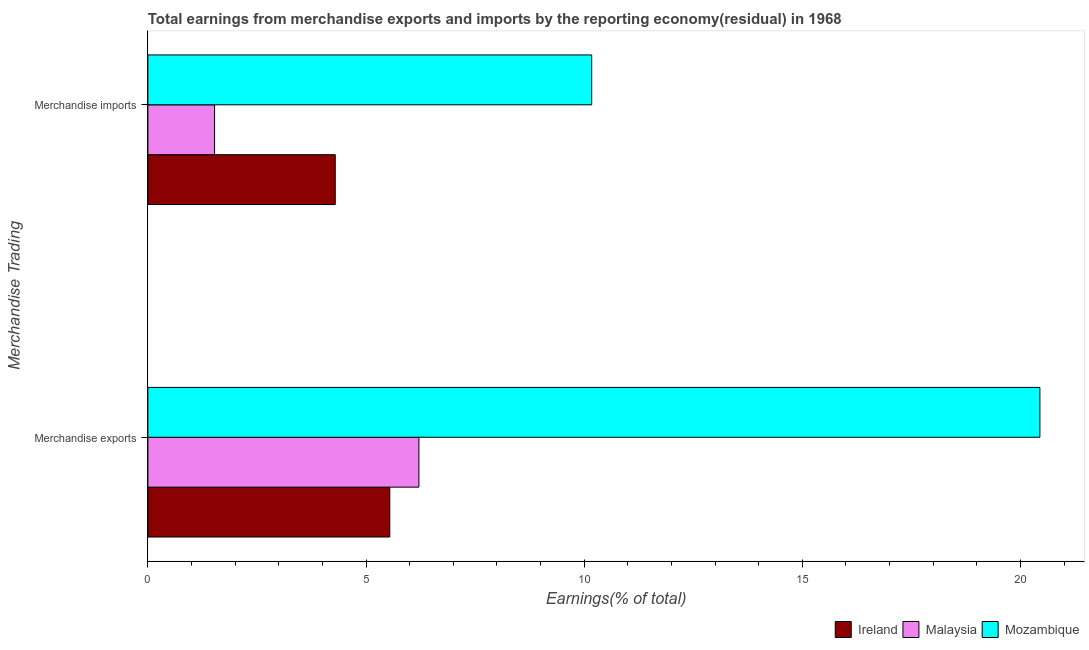Are the number of bars per tick equal to the number of legend labels?
Your answer should be compact. Yes. How many bars are there on the 2nd tick from the top?
Make the answer very short. 3. What is the earnings from merchandise exports in Malaysia?
Your answer should be very brief. 6.21. Across all countries, what is the maximum earnings from merchandise exports?
Your answer should be compact. 20.44. Across all countries, what is the minimum earnings from merchandise exports?
Your response must be concise. 5.54. In which country was the earnings from merchandise exports maximum?
Offer a terse response. Mozambique. In which country was the earnings from merchandise imports minimum?
Your answer should be compact. Malaysia. What is the total earnings from merchandise exports in the graph?
Your response must be concise. 32.2. What is the difference between the earnings from merchandise exports in Mozambique and that in Ireland?
Your answer should be compact. 14.9. What is the difference between the earnings from merchandise exports in Malaysia and the earnings from merchandise imports in Ireland?
Keep it short and to the point. 1.92. What is the average earnings from merchandise exports per country?
Make the answer very short. 10.73. What is the difference between the earnings from merchandise imports and earnings from merchandise exports in Ireland?
Your answer should be very brief. -1.25. In how many countries, is the earnings from merchandise imports greater than 16 %?
Offer a terse response. 0. What is the ratio of the earnings from merchandise exports in Mozambique to that in Ireland?
Offer a very short reply. 3.69. Is the earnings from merchandise imports in Ireland less than that in Malaysia?
Your answer should be compact. No. What does the 1st bar from the top in Merchandise exports represents?
Ensure brevity in your answer.  Mozambique. What does the 3rd bar from the bottom in Merchandise exports represents?
Your response must be concise. Mozambique. Are all the bars in the graph horizontal?
Provide a short and direct response. Yes. What is the difference between two consecutive major ticks on the X-axis?
Keep it short and to the point. 5. Does the graph contain grids?
Your response must be concise. No. Where does the legend appear in the graph?
Offer a very short reply. Bottom right. How many legend labels are there?
Your response must be concise. 3. How are the legend labels stacked?
Provide a short and direct response. Horizontal. What is the title of the graph?
Ensure brevity in your answer.  Total earnings from merchandise exports and imports by the reporting economy(residual) in 1968. What is the label or title of the X-axis?
Offer a very short reply. Earnings(% of total). What is the label or title of the Y-axis?
Your answer should be compact. Merchandise Trading. What is the Earnings(% of total) of Ireland in Merchandise exports?
Offer a very short reply. 5.54. What is the Earnings(% of total) in Malaysia in Merchandise exports?
Keep it short and to the point. 6.21. What is the Earnings(% of total) in Mozambique in Merchandise exports?
Make the answer very short. 20.44. What is the Earnings(% of total) of Ireland in Merchandise imports?
Offer a very short reply. 4.29. What is the Earnings(% of total) of Malaysia in Merchandise imports?
Offer a terse response. 1.53. What is the Earnings(% of total) of Mozambique in Merchandise imports?
Your response must be concise. 10.17. Across all Merchandise Trading, what is the maximum Earnings(% of total) of Ireland?
Ensure brevity in your answer.  5.54. Across all Merchandise Trading, what is the maximum Earnings(% of total) in Malaysia?
Offer a very short reply. 6.21. Across all Merchandise Trading, what is the maximum Earnings(% of total) of Mozambique?
Give a very brief answer. 20.44. Across all Merchandise Trading, what is the minimum Earnings(% of total) of Ireland?
Keep it short and to the point. 4.29. Across all Merchandise Trading, what is the minimum Earnings(% of total) in Malaysia?
Keep it short and to the point. 1.53. Across all Merchandise Trading, what is the minimum Earnings(% of total) in Mozambique?
Provide a succinct answer. 10.17. What is the total Earnings(% of total) in Ireland in the graph?
Your answer should be very brief. 9.84. What is the total Earnings(% of total) in Malaysia in the graph?
Your answer should be very brief. 7.74. What is the total Earnings(% of total) in Mozambique in the graph?
Keep it short and to the point. 30.62. What is the difference between the Earnings(% of total) in Ireland in Merchandise exports and that in Merchandise imports?
Give a very brief answer. 1.25. What is the difference between the Earnings(% of total) in Malaysia in Merchandise exports and that in Merchandise imports?
Provide a short and direct response. 4.68. What is the difference between the Earnings(% of total) in Mozambique in Merchandise exports and that in Merchandise imports?
Provide a short and direct response. 10.27. What is the difference between the Earnings(% of total) of Ireland in Merchandise exports and the Earnings(% of total) of Malaysia in Merchandise imports?
Offer a very short reply. 4.02. What is the difference between the Earnings(% of total) in Ireland in Merchandise exports and the Earnings(% of total) in Mozambique in Merchandise imports?
Your answer should be compact. -4.63. What is the difference between the Earnings(% of total) of Malaysia in Merchandise exports and the Earnings(% of total) of Mozambique in Merchandise imports?
Offer a very short reply. -3.96. What is the average Earnings(% of total) in Ireland per Merchandise Trading?
Give a very brief answer. 4.92. What is the average Earnings(% of total) of Malaysia per Merchandise Trading?
Offer a very short reply. 3.87. What is the average Earnings(% of total) of Mozambique per Merchandise Trading?
Give a very brief answer. 15.31. What is the difference between the Earnings(% of total) of Ireland and Earnings(% of total) of Malaysia in Merchandise exports?
Offer a very short reply. -0.67. What is the difference between the Earnings(% of total) of Ireland and Earnings(% of total) of Mozambique in Merchandise exports?
Offer a terse response. -14.9. What is the difference between the Earnings(% of total) of Malaysia and Earnings(% of total) of Mozambique in Merchandise exports?
Keep it short and to the point. -14.23. What is the difference between the Earnings(% of total) of Ireland and Earnings(% of total) of Malaysia in Merchandise imports?
Your answer should be compact. 2.77. What is the difference between the Earnings(% of total) in Ireland and Earnings(% of total) in Mozambique in Merchandise imports?
Keep it short and to the point. -5.88. What is the difference between the Earnings(% of total) in Malaysia and Earnings(% of total) in Mozambique in Merchandise imports?
Your response must be concise. -8.64. What is the ratio of the Earnings(% of total) of Ireland in Merchandise exports to that in Merchandise imports?
Provide a short and direct response. 1.29. What is the ratio of the Earnings(% of total) in Malaysia in Merchandise exports to that in Merchandise imports?
Provide a short and direct response. 4.06. What is the ratio of the Earnings(% of total) in Mozambique in Merchandise exports to that in Merchandise imports?
Give a very brief answer. 2.01. What is the difference between the highest and the second highest Earnings(% of total) of Ireland?
Provide a short and direct response. 1.25. What is the difference between the highest and the second highest Earnings(% of total) in Malaysia?
Your answer should be very brief. 4.68. What is the difference between the highest and the second highest Earnings(% of total) in Mozambique?
Make the answer very short. 10.27. What is the difference between the highest and the lowest Earnings(% of total) of Ireland?
Give a very brief answer. 1.25. What is the difference between the highest and the lowest Earnings(% of total) in Malaysia?
Offer a very short reply. 4.68. What is the difference between the highest and the lowest Earnings(% of total) in Mozambique?
Provide a succinct answer. 10.27. 